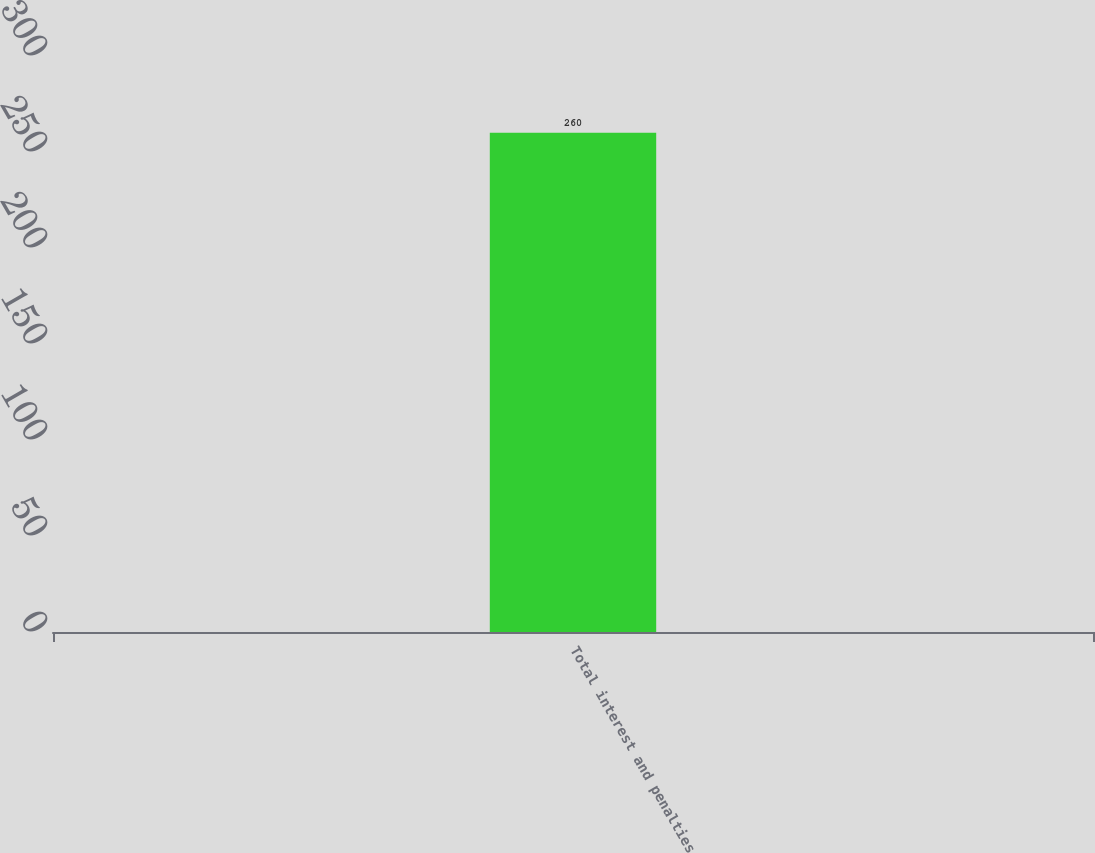Convert chart to OTSL. <chart><loc_0><loc_0><loc_500><loc_500><bar_chart><fcel>Total interest and penalties<nl><fcel>260<nl></chart> 